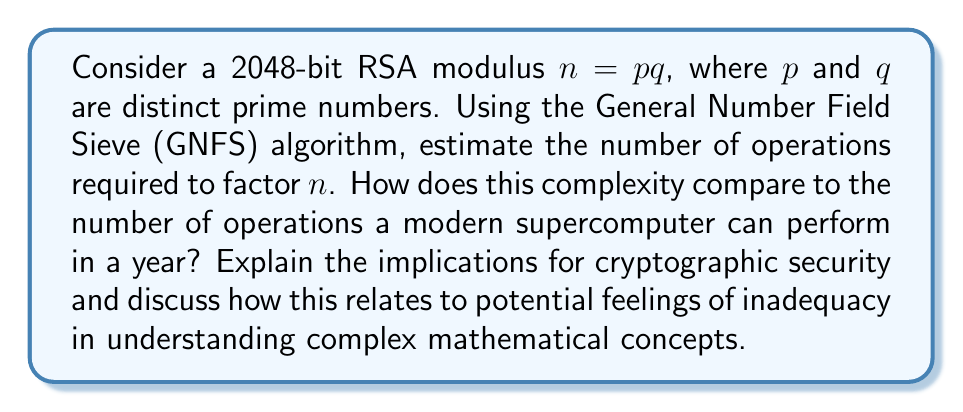Can you answer this question? Let's approach this step-by-step:

1) The complexity of the GNFS algorithm for factoring an integer $n$ is approximately:

   $$O(e^{((64/9)^{1/3} + o(1))(\ln n)^{1/3}(\ln \ln n)^{2/3}})$$

2) For a 2048-bit RSA modulus, $n$ is approximately $2^{2048}$. Let's substitute this into our complexity formula:

   $$O(e^{((64/9)^{1/3} + o(1))(\ln 2^{2048})^{1/3}(\ln \ln 2^{2048})^{2/3}})$$

3) Simplifying:
   $$O(e^{((64/9)^{1/3} + o(1))(2048 \ln 2)^{1/3}(\ln(2048 \ln 2))^{2/3}})$$

4) This evaluates to approximately $2^{112}$ operations.

5) A modern supercomputer can perform about $10^{18}$ operations per second. In a year, that's about $10^{18} * 60 * 60 * 24 * 365 \approx 3.15 * 10^{25}$ operations.

6) $2^{112}$ is approximately $5.19 * 10^{33}$, which is about $1.65 * 10^8$ times more than what a supercomputer can do in a year.

7) This means it would take about 165 million years for a modern supercomputer to factor a 2048-bit RSA modulus using the GNFS algorithm.

Implications for cryptographic security:
This immense complexity provides strong security for RSA encryption with 2048-bit keys. It demonstrates why large prime factors are crucial in cryptography.

Relating to feelings of inadequacy:
Understanding these complex concepts can be overwhelming. It's important to recognize that even experts in the field don't always grasp every detail immediately. The complexity of these algorithms is a result of decades of mathematical research. Feeling challenged by such concepts is normal and doesn't reflect on one's intelligence or capability. Instead, it's an opportunity for growth and learning.
Answer: $2^{112}$ operations, approximately 165 million years for a modern supercomputer. 